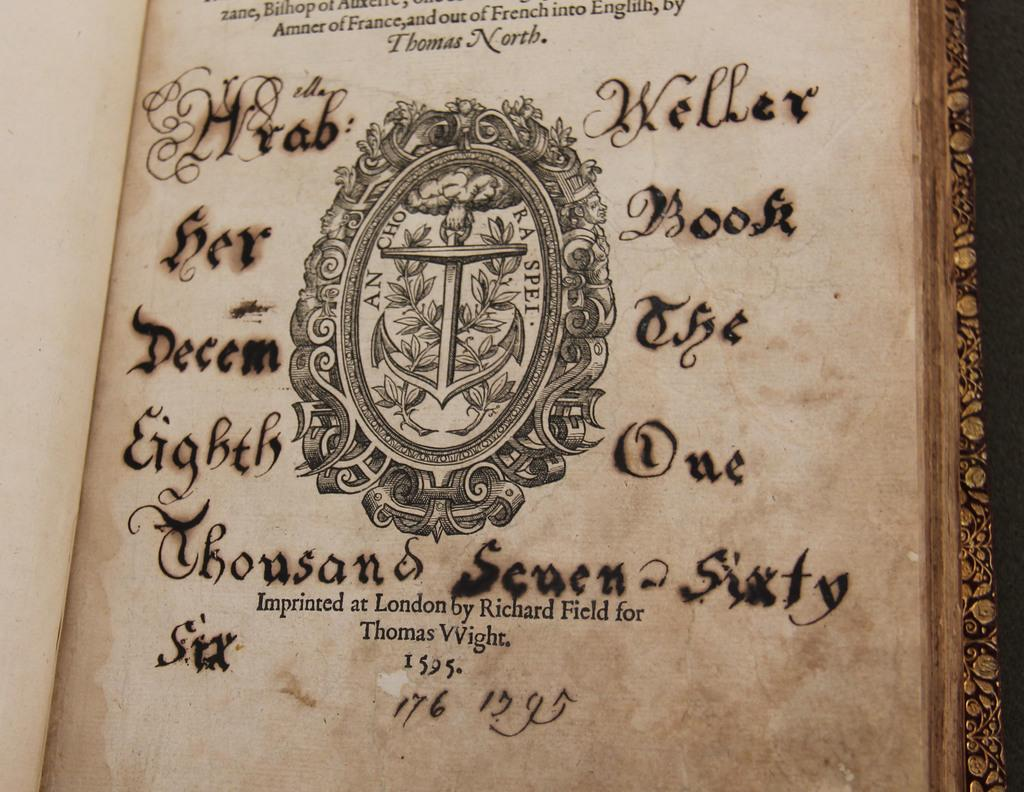<image>
Write a terse but informative summary of the picture. A page from an old book dating back to 1595 imprinted for Thomas Wight is shown. 